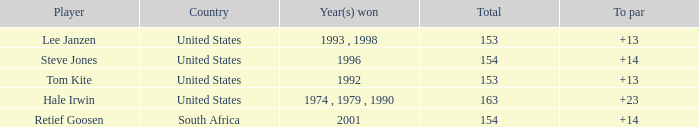In what year did the United States win To par greater than 14 1974 , 1979 , 1990. 